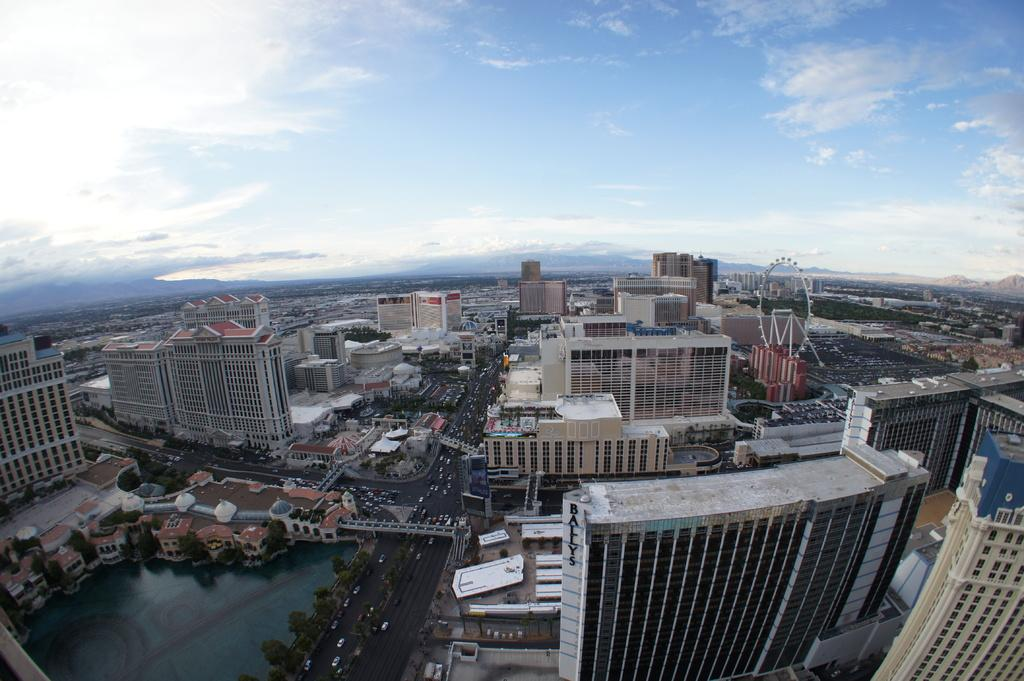What type of structures can be seen in the image? There are many buildings, houses, and a giant wheel in the image. What can be found between the structures in the image? There are roads and trees visible in the image. What is moving on the roads in the image? There are vehicles in the image. Is there any water visible in the image? Yes, there is water visible in the image. What is the condition of the sky in the image? The sky is cloudy at the top of the image. Can you tell me how many pancakes are being served by the monkey in the image? There is no monkey or pancakes present in the image. What type of things are being sold by the vendor in the image? The image does not show any vendors or things being sold. 